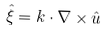<formula> <loc_0><loc_0><loc_500><loc_500>\hat { \xi } = k \cdot \nabla \times \hat { u }</formula> 